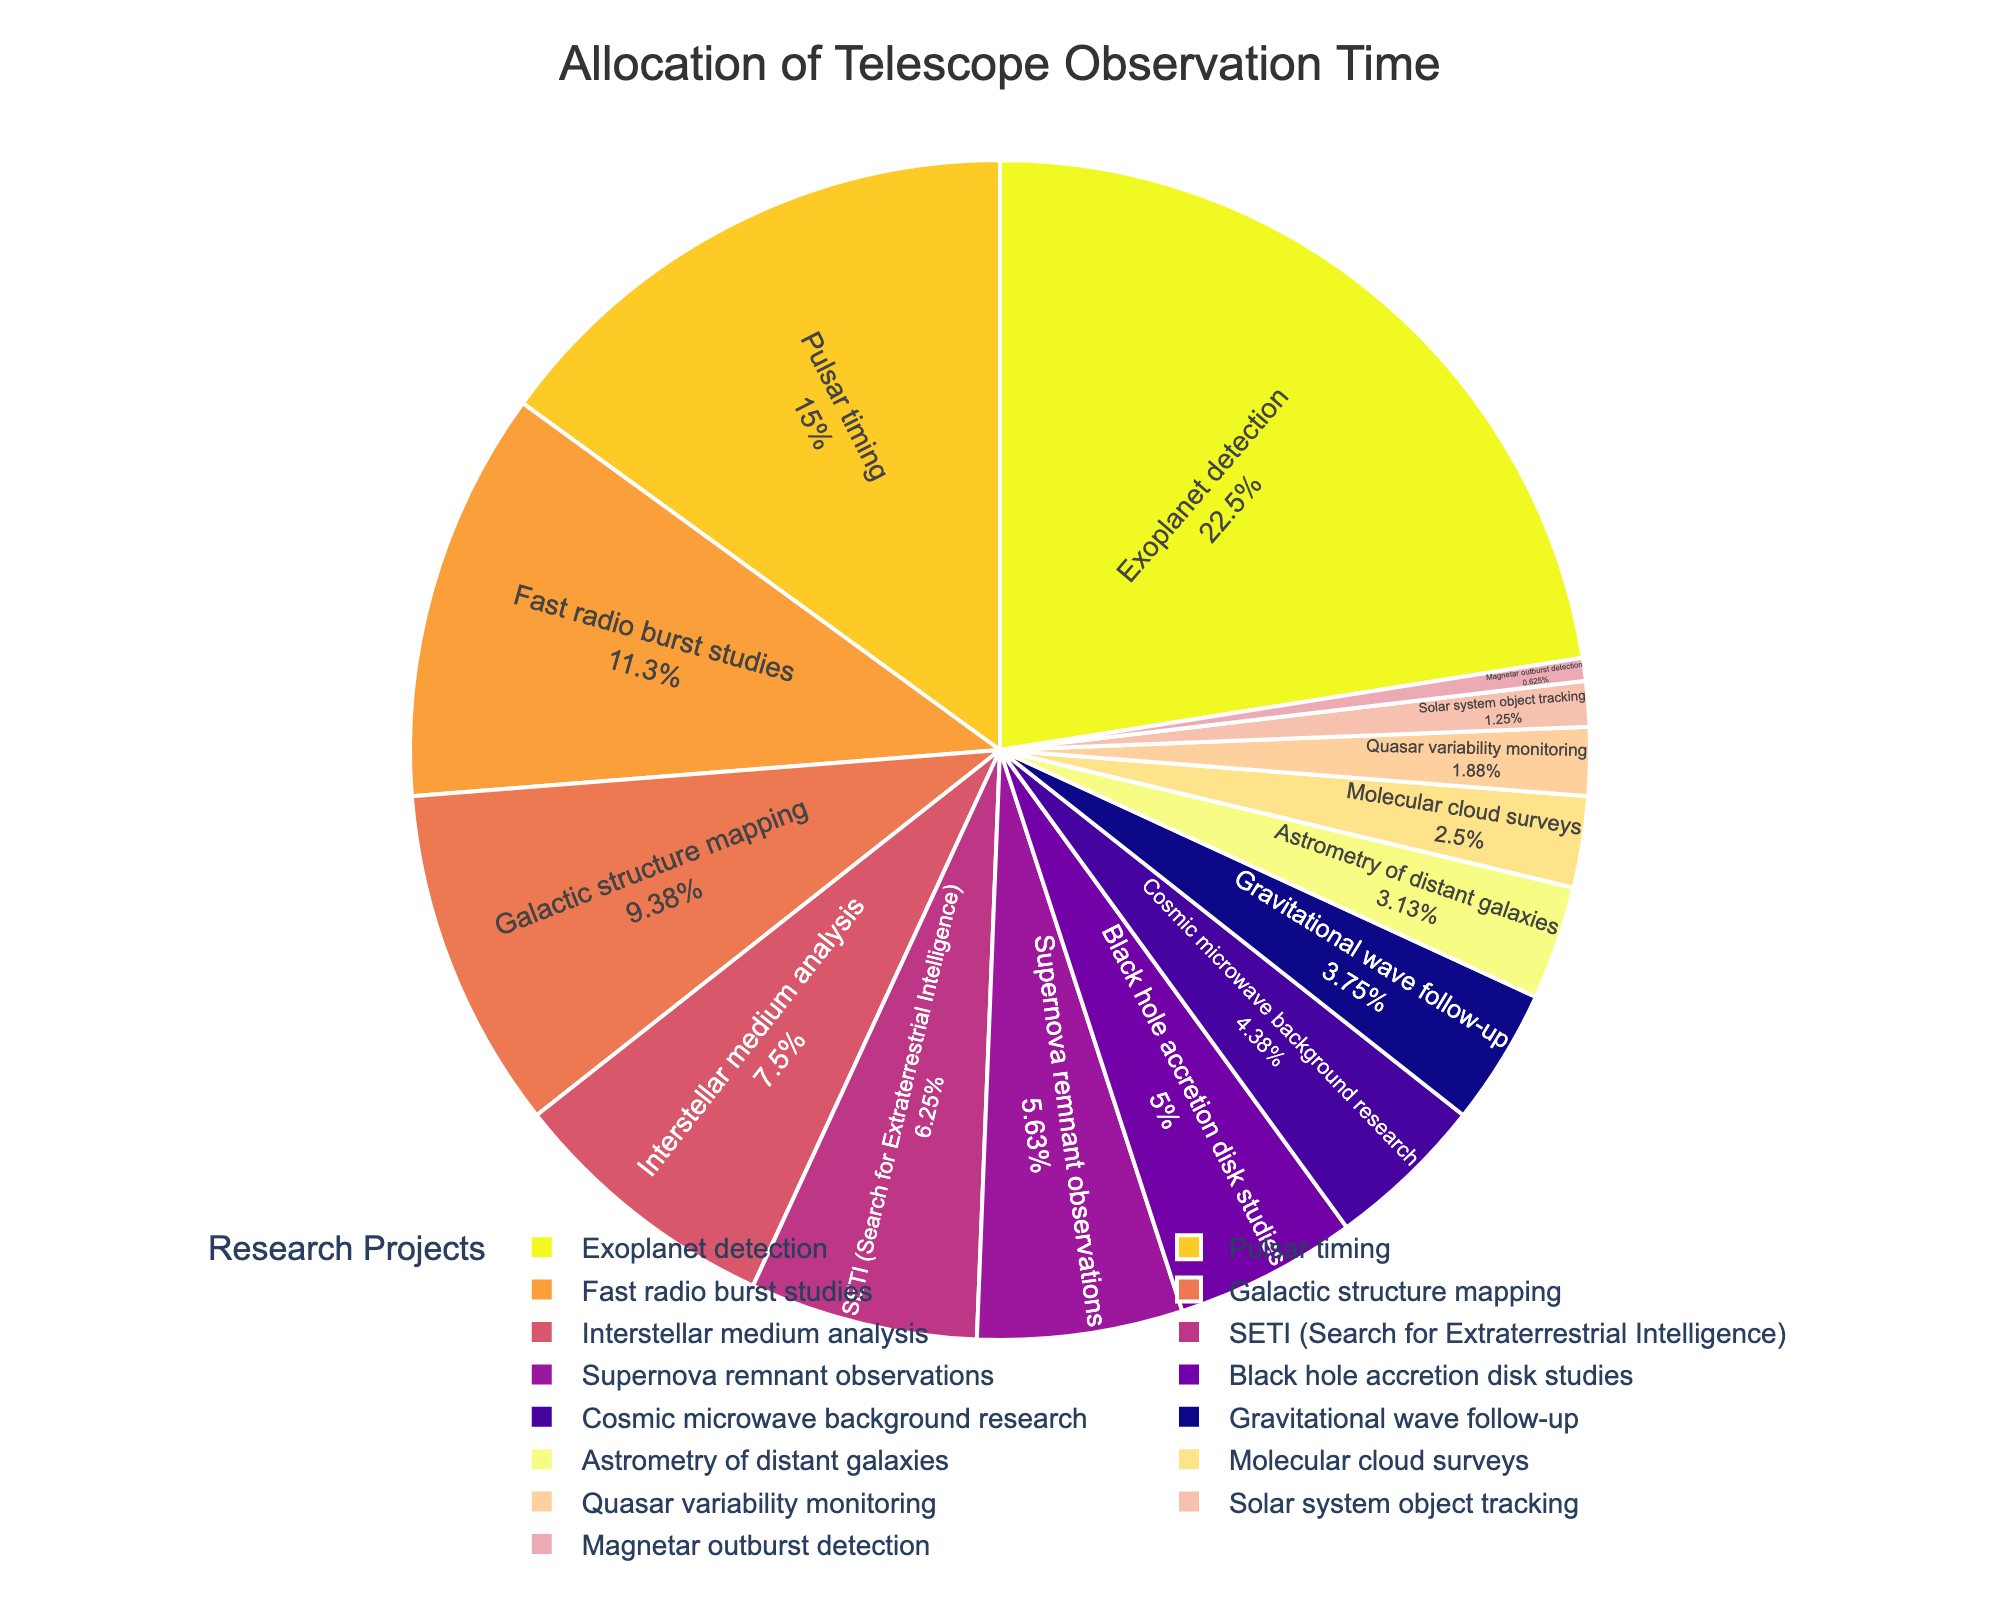What is the total observation time allocated to Exoplanet detection and Pulsar timing combined? Exoplanet detection has 720 hours and Pulsar timing has 480 hours. Adding these together: 720 + 480 = 1200 hours
Answer: 1200 hours Which project has the least allocated observation time? The project with the smallest portion in the pie chart is Magnetar outburst detection.
Answer: Magnetar outburst detection How does the observation time allocated to Fast radio burst studies compare to that of Interstellar medium analysis? Fast radio burst studies account for 360 hours, while Interstellar medium analysis has 240 hours. By comparison, Fast radio burst studies have more observation time allocated.
Answer: Fast radio burst studies have more What percentage of the total observation time is devoted to projects related to black hole studies and gravitational wave follow-up combined? Black hole accretion disk studies have 160 hours, and Gravitational wave follow-up has 120 hours. The combined time is 160 + 120 = 280 hours. To find the percentage, divide this by the total observation time which is 3220 hours and multiply by 100. (280 / 3220) * 100 ≈ 8.7%
Answer: 8.7% Is more observation time allocated to Solar system object tracking or Quasar variability monitoring? By comparing the sizes in the pie chart, Solar system object tracking has 40 hours, and Quasar variability monitoring has 60 hours.
Answer: Quasar variability monitoring What scientific objective has the third-highest allocation of telescope observation time? By looking at the size of the pie sections, the third largest section represents Fast radio burst studies with 360 hours.
Answer: Fast radio burst studies If the observation time allocated to Supernova remnant observations were doubled, what would the new duration be? Supernova remnant observations currently have 180 hours. Doubling this amount: 180 * 2 = 360 hours
Answer: 360 hours 